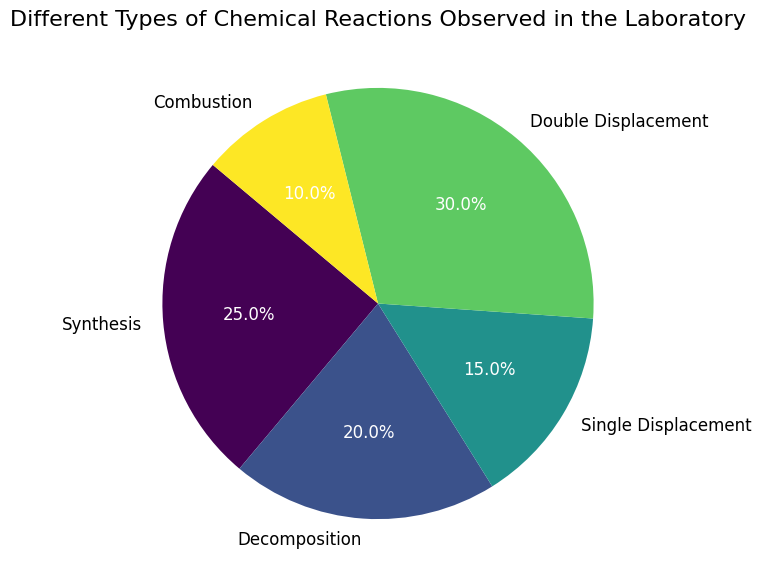What percentage of chemical reactions observed in the laboratory are Combustion reactions? To find the percentage of Combustion reactions, look at the figure where it shows the Combustion segment. The autopct displayed in the pie chart shows the percentage directly: 10%
Answer: 10% Which type of reaction is observed the most in the laboratory? Observe all the segments in the pie chart and identify the largest wedge. The 'Double Displacement' segment is the largest, indicating it's the most observed reaction type.
Answer: Double Displacement How many more Synthesis reactions are observed compared to Combustion reactions? Look at the counts provided: Synthesis has 25 observations, and Combustion has 10. Subtract Combustion from Synthesis: 25 - 10 = 15.
Answer: 15 Which type of reaction has a smaller observation count, Single Displacement or Decomposition? Observe the pie chart and look for the segments labeled 'Single Displacement' and 'Decomposition'. The percentage shows that Single Displacement (15) is less than Decomposition (20).
Answer: Single Displacement What percentage of reactions observed are either Synthesis or Decomposition? Add the counts for Synthesis (25) and Decomposition (20), then divide by the total number of reactions (100): (25 + 20) / 100 = 45%.
Answer: 45% What is the total number of reactions observed in the laboratory? Sum the counts for all reaction types: 25 (Synthesis) + 20 (Decomposition) + 15 (Single Displacement) + 30 (Double Displacement) + 10 (Combustion) = 100.
Answer: 100 Which segment is colored the darkest in the pie chart and what reaction does it represent? The colors typically get darker as the percentage decreases, so the darkest colored wedge is representing 'Combustion'.
Answer: Combustion Are there more Double Displacement reactions than the combined total of Single Displacement and Combustion reactions? Compare the count: Double Displacement has 30, whereas Single Displacement (15) + Combustion (10) is 25. 30 is greater than 25.
Answer: Yes What is the difference in the number of reactions observed between the most frequent and the least frequent reaction types? Identify the most frequent (Double Displacement, 30) and the least frequent (Combustion, 10) reaction types. Subtract the least frequent from the most frequent: 30 - 10 = 20.
Answer: 20 